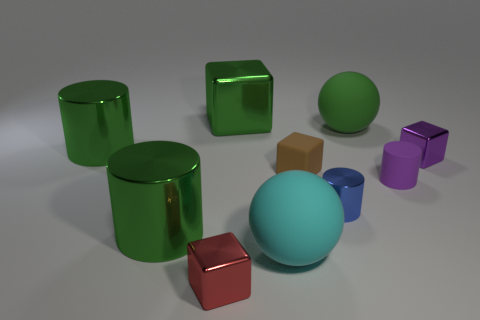Subtract all purple cylinders. How many cylinders are left? 3 Subtract 4 blocks. How many blocks are left? 0 Subtract all blue cylinders. How many cylinders are left? 3 Subtract 0 red spheres. How many objects are left? 10 Subtract all cylinders. How many objects are left? 6 Subtract all red cubes. Subtract all yellow cylinders. How many cubes are left? 3 Subtract all brown balls. How many gray blocks are left? 0 Subtract all tiny red objects. Subtract all large brown rubber blocks. How many objects are left? 9 Add 5 blue things. How many blue things are left? 6 Add 8 brown cubes. How many brown cubes exist? 9 